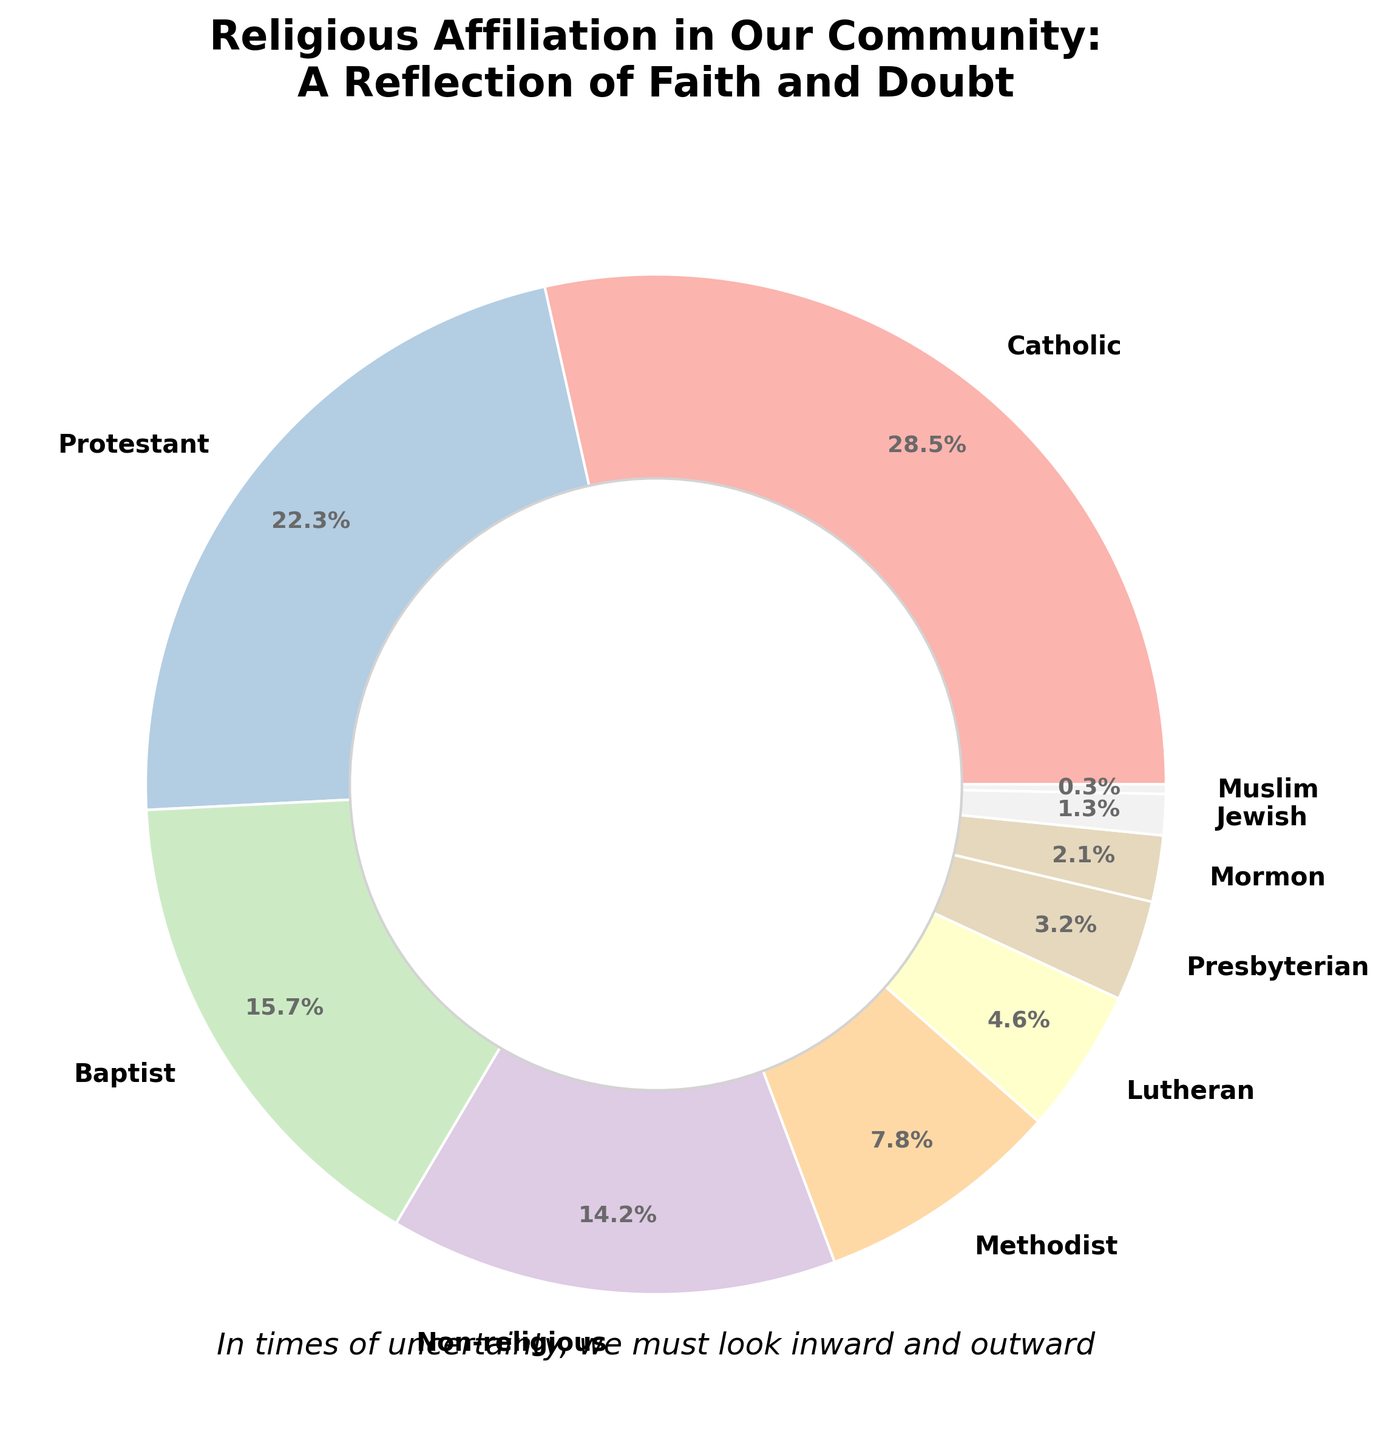Which religion has the highest percentage in the local community? By looking directly at the pie chart, the largest section represents the Catholic faith. The label indicates that Catholics make up 28.5% of the local community.
Answer: Catholic What is the combined percentage of Baptist and Methodist affiliates? According to the pie chart, Baptists represent 15.7% and Methodists represent 7.8% of the community. Combining these percentages yields 15.7 + 7.8 = 23.5%.
Answer: 23.5% How much greater is the Catholic percentage than the Presbyterian percentage? From the pie chart, the Catholic percentage is 28.5%, and the Presbyterian percentage is 3.2%. Subtracting the two gives 28.5 - 3.2 = 25.3%.
Answer: 25.3% Is the percentage of non-religious people greater than that of Methodists? The pie chart shows non-religious people at 14.2% and Methodists at 7.8%. Since 14.2% is greater than 7.8%, the answer is yes.
Answer: Yes Which three religions have the smallest percentages? By identifying the smallest slices in the pie chart, we can see they are for Muslim (0.3%), Jewish (1.3%), and Mormon (2.1%).
Answer: Muslim, Jewish, Mormon What is the average percentage of the Protestant, Baptist, and Methodist affiliations? The percentages are Protestant: 22.3%, Baptist: 15.7%, and Methodist: 7.8%. The sum is 22.3 + 15.7 + 7.8 = 45.8. Dividing by 3 for the average: 45.8 / 3 ≈ 15.27%.
Answer: 15.27% How does the percentage of Lutherans compare to that of Catholics? Referring to the pie chart, Lutherans make up 4.6% and Catholics make up 28.5%. Since 4.6% is less than 28.5%, Lutherans have a smaller percentage compared to Catholics.
Answer: Lutherans have a smaller percentage What is the difference in percentage between the largest and the smallest religious affiliations? The largest percentage is Catholics at 28.5%, and the smallest is Muslims at 0.3%. The difference is 28.5 - 0.3 = 28.2%.
Answer: 28.2% What is the total percentage of Christian denominations listed (Catholic, Protestant, Baptist, Methodist, Lutheran, Presbyterian, Mormon)? Adding up the percentages: Catholic (28.5) + Protestant (22.3) + Baptist (15.7) + Methodist (7.8) + Lutheran (4.6) + Presbyterian (3.2) + Mormon (2.1) = 84.2%.
Answer: 84.2% 